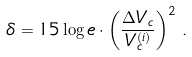Convert formula to latex. <formula><loc_0><loc_0><loc_500><loc_500>\delta = 1 5 \log e \cdot \left ( \frac { \Delta V _ { c } } { V _ { c } ^ { ( i ) } } \right ) ^ { 2 } \, .</formula> 